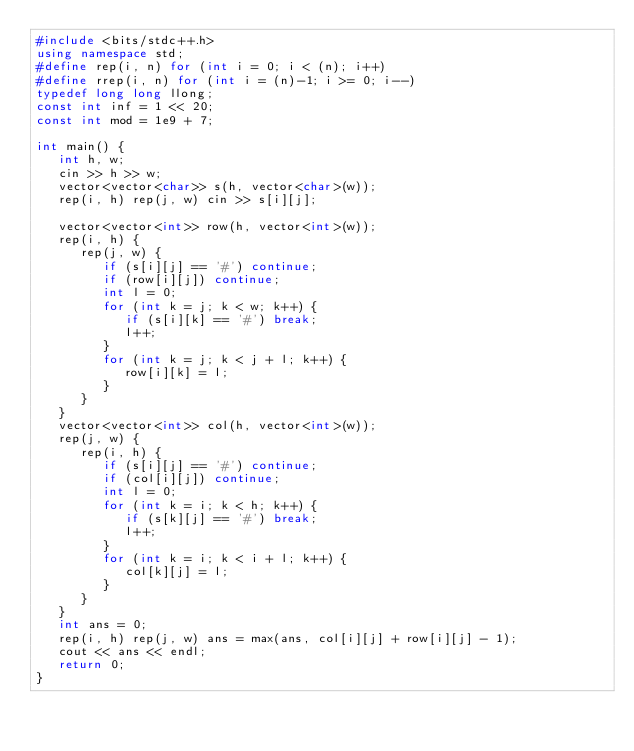Convert code to text. <code><loc_0><loc_0><loc_500><loc_500><_C++_>#include <bits/stdc++.h>
using namespace std;
#define rep(i, n) for (int i = 0; i < (n); i++)
#define rrep(i, n) for (int i = (n)-1; i >= 0; i--)
typedef long long llong;
const int inf = 1 << 20;
const int mod = 1e9 + 7;

int main() {
   int h, w;
   cin >> h >> w;
   vector<vector<char>> s(h, vector<char>(w));
   rep(i, h) rep(j, w) cin >> s[i][j];

   vector<vector<int>> row(h, vector<int>(w));
   rep(i, h) {
      rep(j, w) {
         if (s[i][j] == '#') continue;
         if (row[i][j]) continue;
         int l = 0;
         for (int k = j; k < w; k++) {
            if (s[i][k] == '#') break;
            l++;
         }
         for (int k = j; k < j + l; k++) {
            row[i][k] = l;
         }
      }
   }
   vector<vector<int>> col(h, vector<int>(w));
   rep(j, w) {
      rep(i, h) {
         if (s[i][j] == '#') continue;
         if (col[i][j]) continue;
         int l = 0;
         for (int k = i; k < h; k++) {
            if (s[k][j] == '#') break;
            l++;
         }
         for (int k = i; k < i + l; k++) {
            col[k][j] = l;
         }
      }
   }
   int ans = 0;
   rep(i, h) rep(j, w) ans = max(ans, col[i][j] + row[i][j] - 1);
   cout << ans << endl;
   return 0;
}</code> 